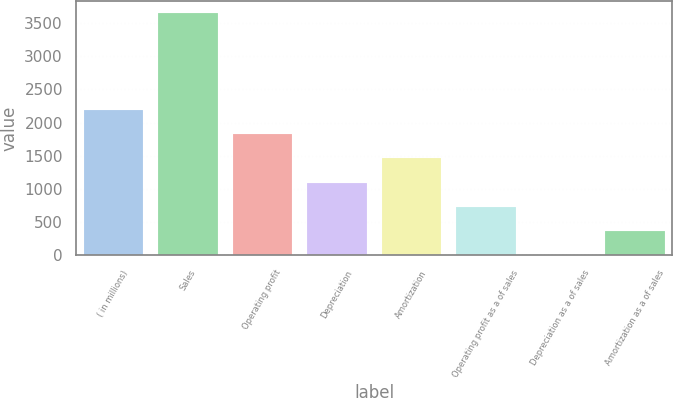Convert chart. <chart><loc_0><loc_0><loc_500><loc_500><bar_chart><fcel>( in millions)<fcel>Sales<fcel>Operating profit<fcel>Depreciation<fcel>Amortization<fcel>Operating profit as a of sales<fcel>Depreciation as a of sales<fcel>Amortization as a of sales<nl><fcel>2193.78<fcel>3655.1<fcel>1828.45<fcel>1097.79<fcel>1463.12<fcel>732.46<fcel>1.8<fcel>367.13<nl></chart> 